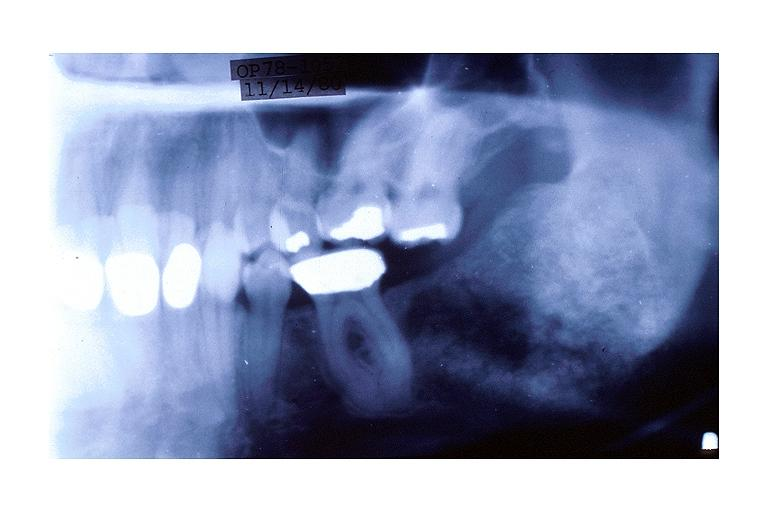does pus in test tube show cemento-ossifying fibroma?
Answer the question using a single word or phrase. No 